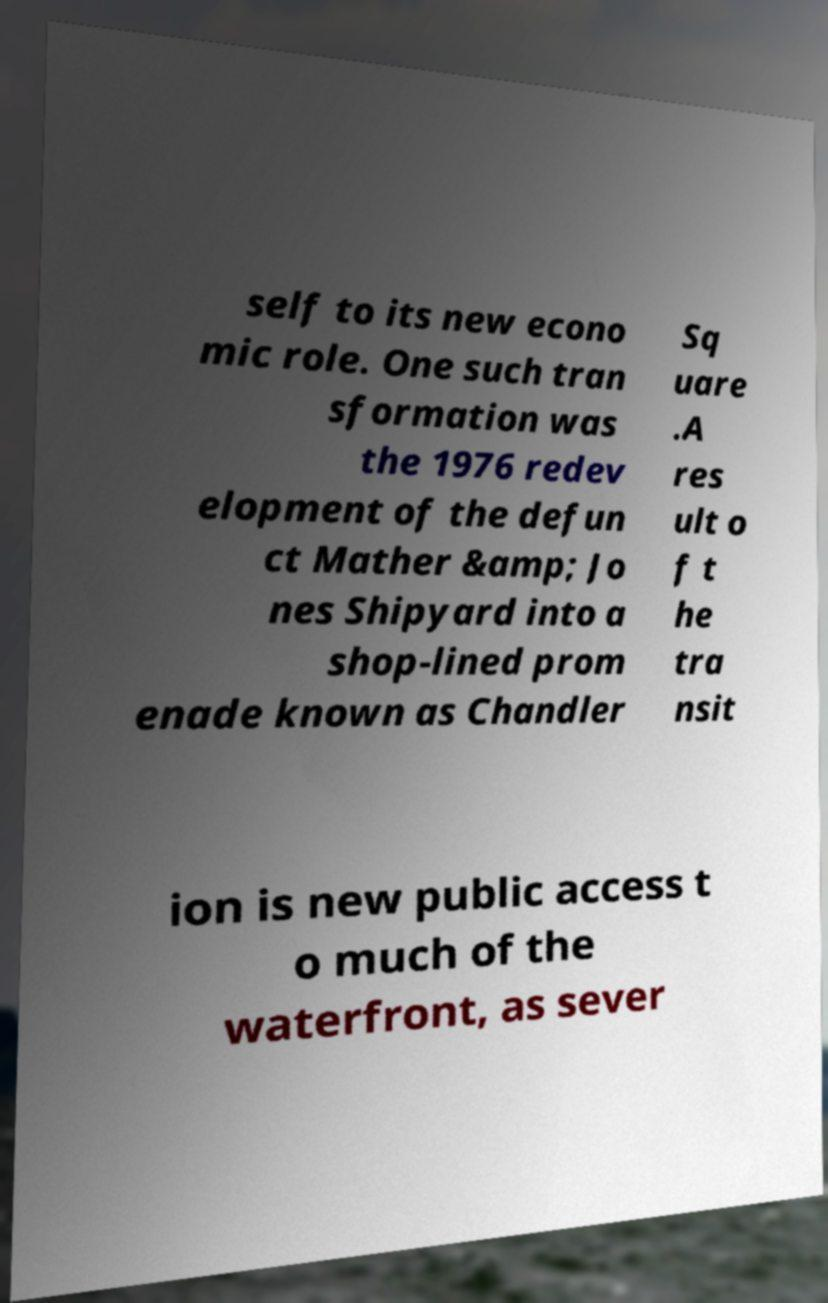There's text embedded in this image that I need extracted. Can you transcribe it verbatim? self to its new econo mic role. One such tran sformation was the 1976 redev elopment of the defun ct Mather &amp; Jo nes Shipyard into a shop-lined prom enade known as Chandler Sq uare .A res ult o f t he tra nsit ion is new public access t o much of the waterfront, as sever 